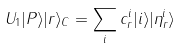Convert formula to latex. <formula><loc_0><loc_0><loc_500><loc_500>U _ { 1 } | P \rangle | r \rangle _ { C } = \sum _ { i } c _ { r } ^ { i } | i \rangle | \eta _ { r } ^ { i } \rangle</formula> 